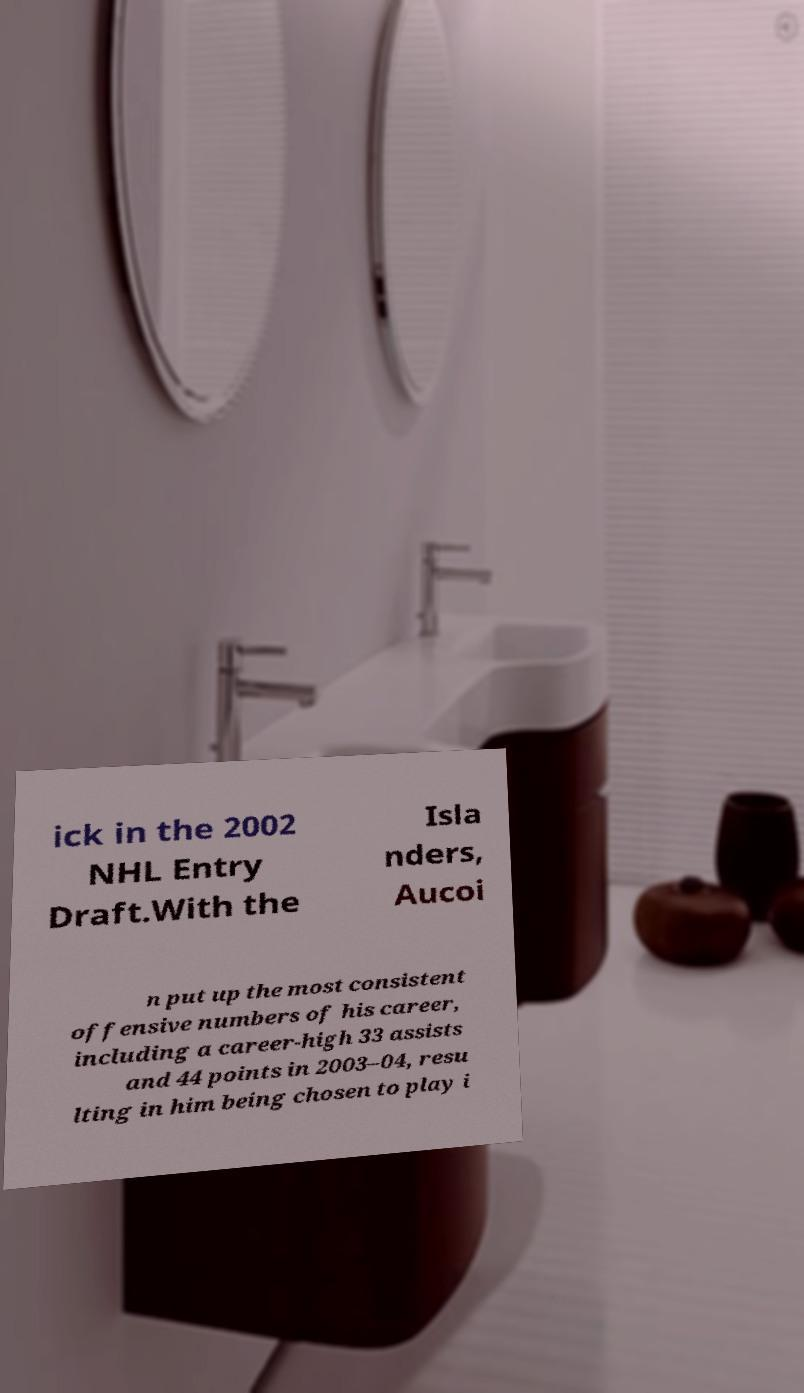Can you accurately transcribe the text from the provided image for me? ick in the 2002 NHL Entry Draft.With the Isla nders, Aucoi n put up the most consistent offensive numbers of his career, including a career-high 33 assists and 44 points in 2003–04, resu lting in him being chosen to play i 